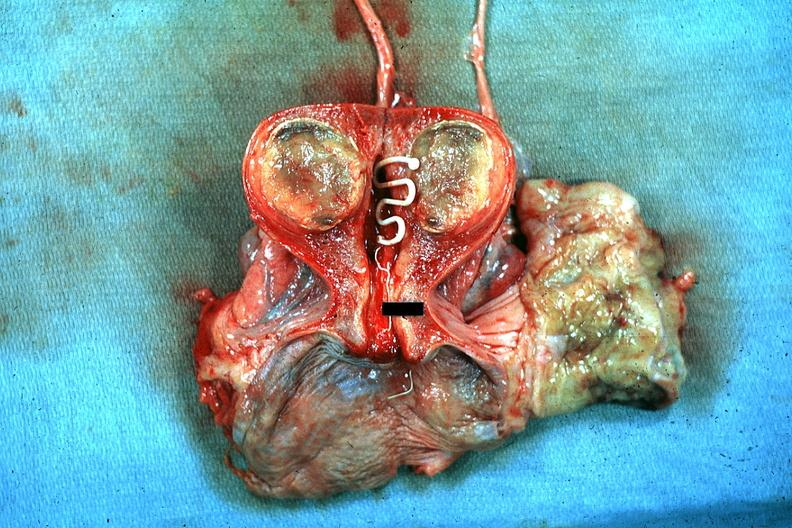s acute lymphocytic leukemia present?
Answer the question using a single word or phrase. No 